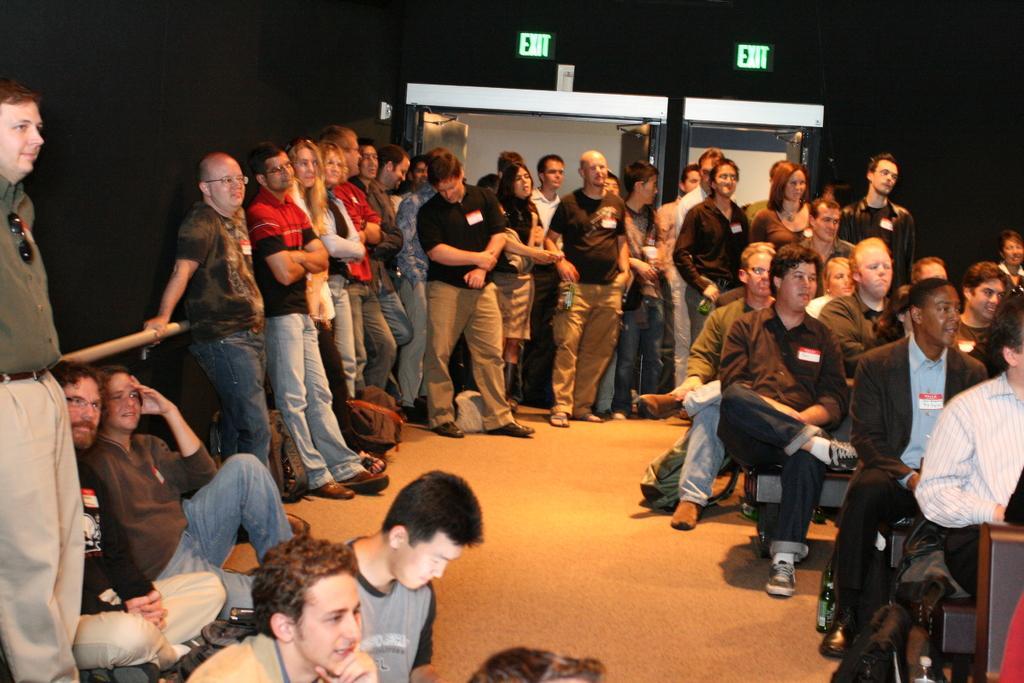Can you describe this image briefly? On the left side, there are men and women. Some of them are standing. On the right side, there are men and women. Some of them are sitting. In the background, there are two sign boards and doors. 